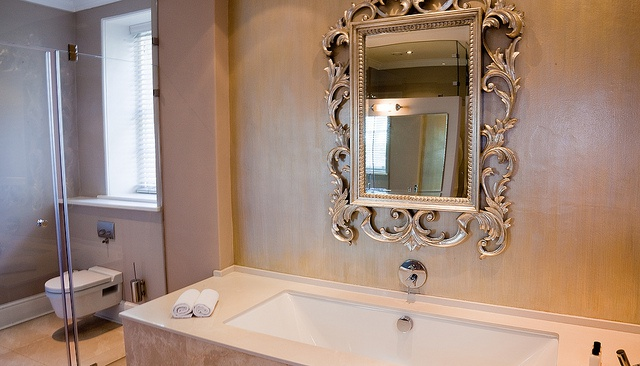Describe the objects in this image and their specific colors. I can see sink in gray, lightgray, tan, and darkgray tones and toilet in gray and darkgray tones in this image. 